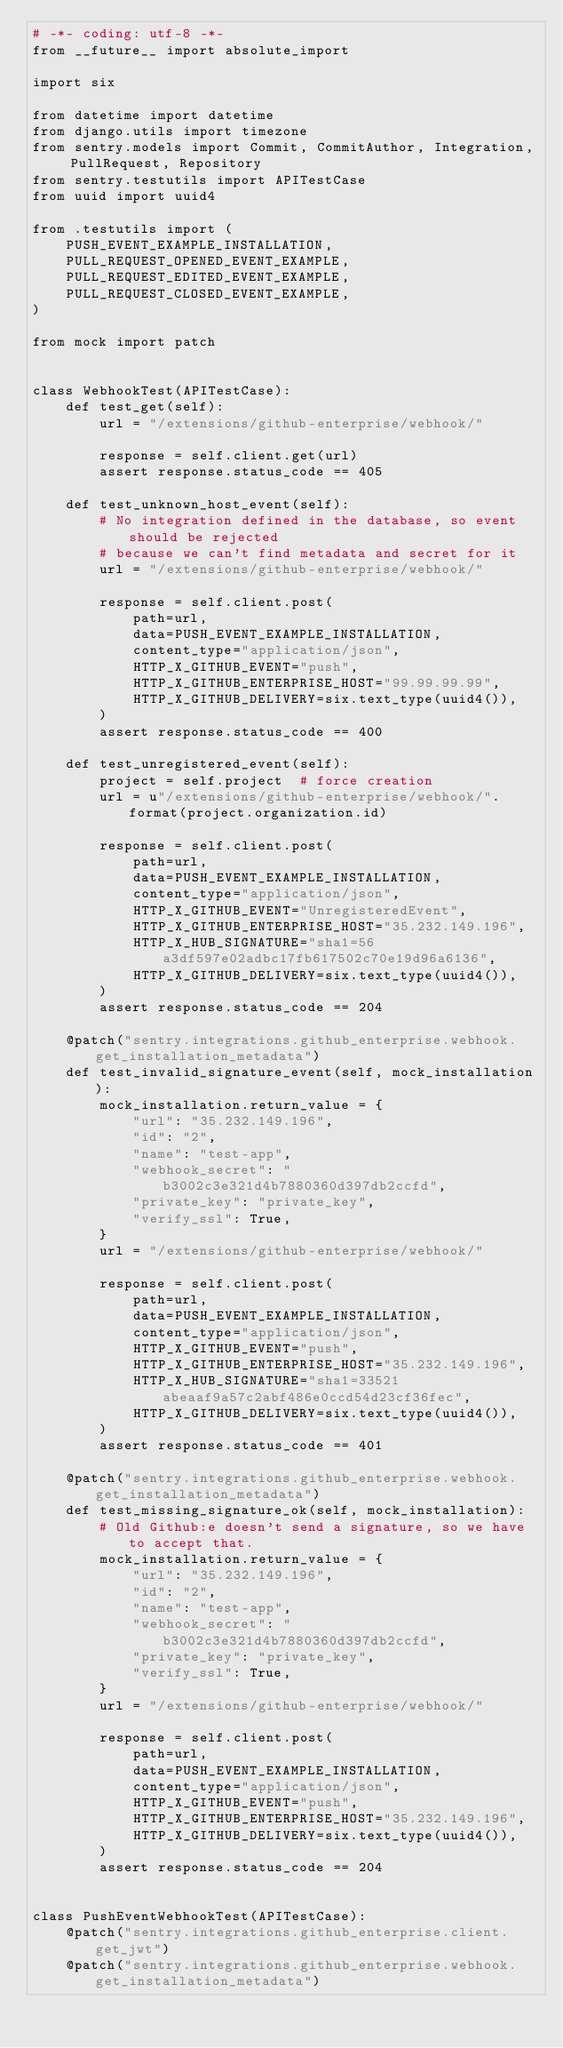Convert code to text. <code><loc_0><loc_0><loc_500><loc_500><_Python_># -*- coding: utf-8 -*-
from __future__ import absolute_import

import six

from datetime import datetime
from django.utils import timezone
from sentry.models import Commit, CommitAuthor, Integration, PullRequest, Repository
from sentry.testutils import APITestCase
from uuid import uuid4

from .testutils import (
    PUSH_EVENT_EXAMPLE_INSTALLATION,
    PULL_REQUEST_OPENED_EVENT_EXAMPLE,
    PULL_REQUEST_EDITED_EVENT_EXAMPLE,
    PULL_REQUEST_CLOSED_EVENT_EXAMPLE,
)

from mock import patch


class WebhookTest(APITestCase):
    def test_get(self):
        url = "/extensions/github-enterprise/webhook/"

        response = self.client.get(url)
        assert response.status_code == 405

    def test_unknown_host_event(self):
        # No integration defined in the database, so event should be rejected
        # because we can't find metadata and secret for it
        url = "/extensions/github-enterprise/webhook/"

        response = self.client.post(
            path=url,
            data=PUSH_EVENT_EXAMPLE_INSTALLATION,
            content_type="application/json",
            HTTP_X_GITHUB_EVENT="push",
            HTTP_X_GITHUB_ENTERPRISE_HOST="99.99.99.99",
            HTTP_X_GITHUB_DELIVERY=six.text_type(uuid4()),
        )
        assert response.status_code == 400

    def test_unregistered_event(self):
        project = self.project  # force creation
        url = u"/extensions/github-enterprise/webhook/".format(project.organization.id)

        response = self.client.post(
            path=url,
            data=PUSH_EVENT_EXAMPLE_INSTALLATION,
            content_type="application/json",
            HTTP_X_GITHUB_EVENT="UnregisteredEvent",
            HTTP_X_GITHUB_ENTERPRISE_HOST="35.232.149.196",
            HTTP_X_HUB_SIGNATURE="sha1=56a3df597e02adbc17fb617502c70e19d96a6136",
            HTTP_X_GITHUB_DELIVERY=six.text_type(uuid4()),
        )
        assert response.status_code == 204

    @patch("sentry.integrations.github_enterprise.webhook.get_installation_metadata")
    def test_invalid_signature_event(self, mock_installation):
        mock_installation.return_value = {
            "url": "35.232.149.196",
            "id": "2",
            "name": "test-app",
            "webhook_secret": "b3002c3e321d4b7880360d397db2ccfd",
            "private_key": "private_key",
            "verify_ssl": True,
        }
        url = "/extensions/github-enterprise/webhook/"

        response = self.client.post(
            path=url,
            data=PUSH_EVENT_EXAMPLE_INSTALLATION,
            content_type="application/json",
            HTTP_X_GITHUB_EVENT="push",
            HTTP_X_GITHUB_ENTERPRISE_HOST="35.232.149.196",
            HTTP_X_HUB_SIGNATURE="sha1=33521abeaaf9a57c2abf486e0ccd54d23cf36fec",
            HTTP_X_GITHUB_DELIVERY=six.text_type(uuid4()),
        )
        assert response.status_code == 401

    @patch("sentry.integrations.github_enterprise.webhook.get_installation_metadata")
    def test_missing_signature_ok(self, mock_installation):
        # Old Github:e doesn't send a signature, so we have to accept that.
        mock_installation.return_value = {
            "url": "35.232.149.196",
            "id": "2",
            "name": "test-app",
            "webhook_secret": "b3002c3e321d4b7880360d397db2ccfd",
            "private_key": "private_key",
            "verify_ssl": True,
        }
        url = "/extensions/github-enterprise/webhook/"

        response = self.client.post(
            path=url,
            data=PUSH_EVENT_EXAMPLE_INSTALLATION,
            content_type="application/json",
            HTTP_X_GITHUB_EVENT="push",
            HTTP_X_GITHUB_ENTERPRISE_HOST="35.232.149.196",
            HTTP_X_GITHUB_DELIVERY=six.text_type(uuid4()),
        )
        assert response.status_code == 204


class PushEventWebhookTest(APITestCase):
    @patch("sentry.integrations.github_enterprise.client.get_jwt")
    @patch("sentry.integrations.github_enterprise.webhook.get_installation_metadata")</code> 